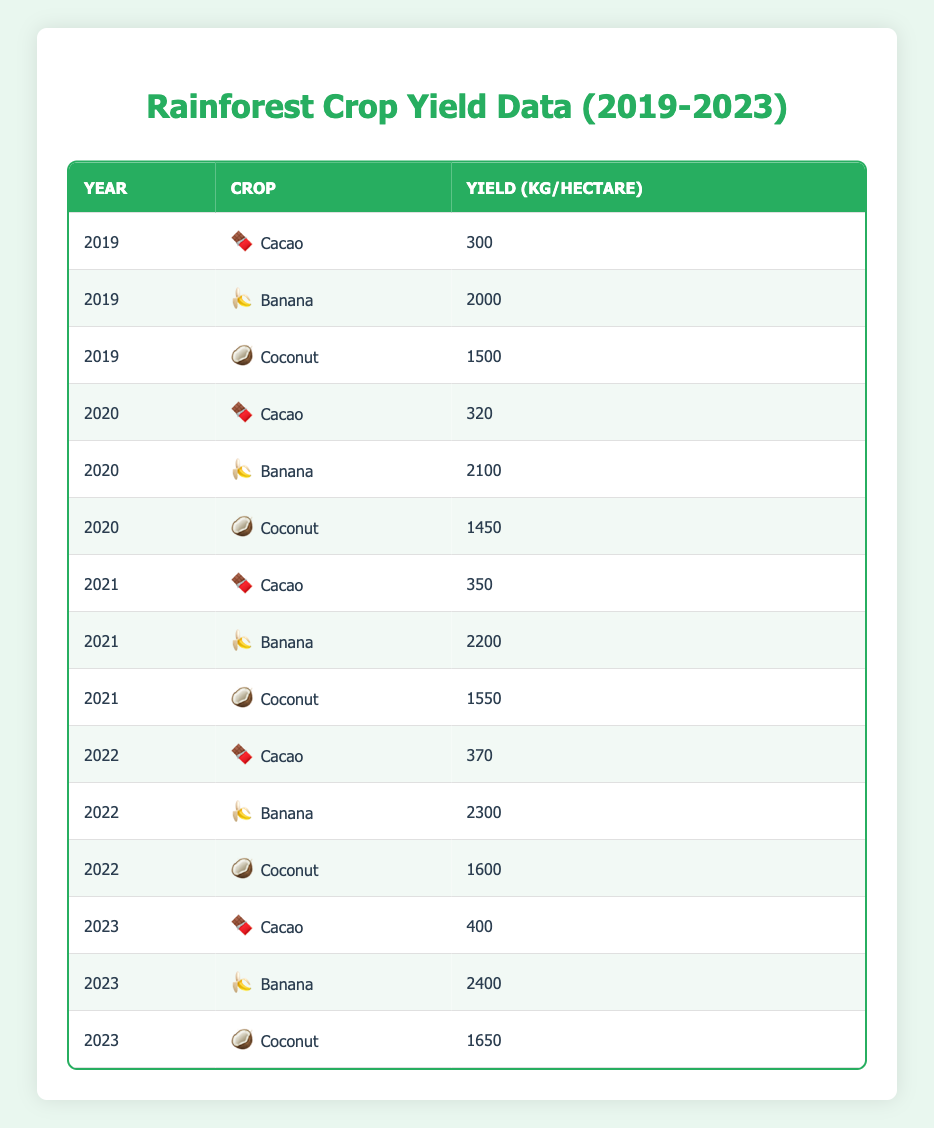What was the yield of Cacao in 2022? In the table, locate the row where the crop is "Cacao" and the year is "2022." The yield in that row shows "370 kg/hectare."
Answer: 370 kg/hectare Which crop had the highest yield in 2023? Check the yields for all crops in 2023. The yield for Banana is "2400 kg/hectare," which is higher than the others (Cacao at 400 and Coconut at 1650).
Answer: Banana What is the average yield of Coconut from 2019 to 2023? Add the yields for Coconut from each year: 1500 (2019) + 1450 (2020) + 1550 (2021) + 1600 (2022) + 1650 (2023) = 7650. Then, divide the sum by the number of years (5) to find the average: 7650 / 5 = 1530.
Answer: 1530 kg/hectare Did the yield of Banana increase every year from 2019 to 2023? Look at the yields of Banana for each year: 2000 (2019), 2100 (2020), 2200 (2021), 2300 (2022), and 2400 (2023). Each yield is greater than the previous year, confirming an increase every year.
Answer: Yes What was the total yield of Cacao over the five years? Find the yields for Cacao: 300 (2019) + 320 (2020) + 350 (2021) + 370 (2022) + 400 (2023) = 1740 kg/hectare summed over those years.
Answer: 1740 kg/hectare 